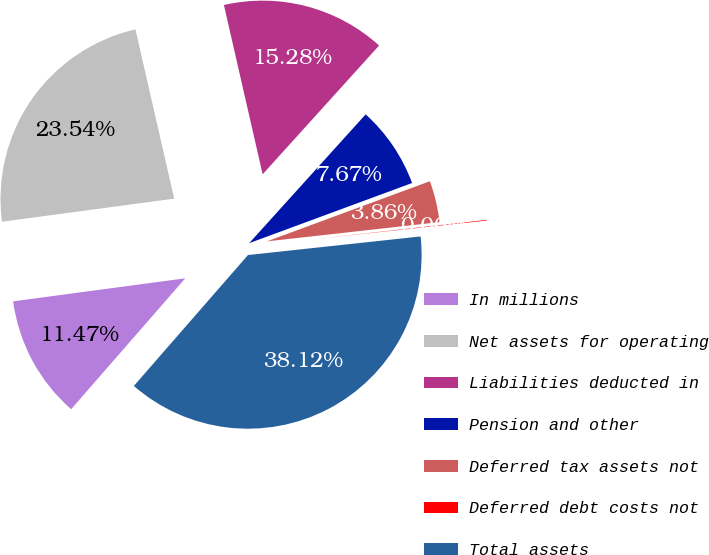Convert chart to OTSL. <chart><loc_0><loc_0><loc_500><loc_500><pie_chart><fcel>In millions<fcel>Net assets for operating<fcel>Liabilities deducted in<fcel>Pension and other<fcel>Deferred tax assets not<fcel>Deferred debt costs not<fcel>Total assets<nl><fcel>11.47%<fcel>23.54%<fcel>15.28%<fcel>7.67%<fcel>3.86%<fcel>0.06%<fcel>38.12%<nl></chart> 